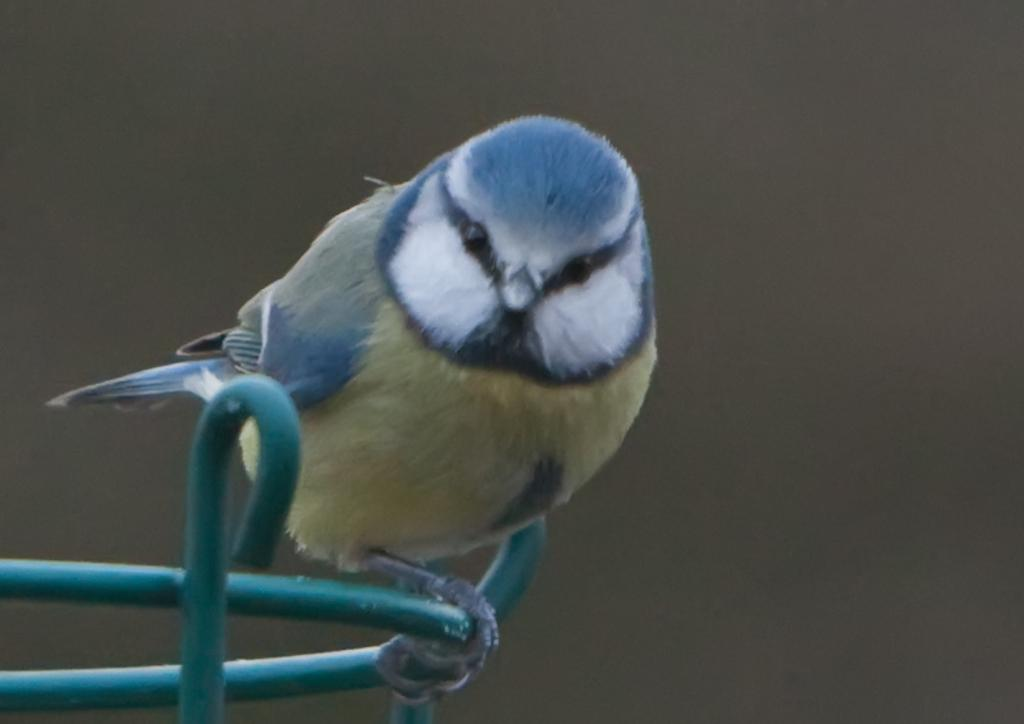What type of animal is present in the image? There is a bird in the image. How many men are visible in the image? There are no men present in the image; it only features a bird. Is there a person interacting with the bird in the image? There is no person present in the image; it only features a bird. 